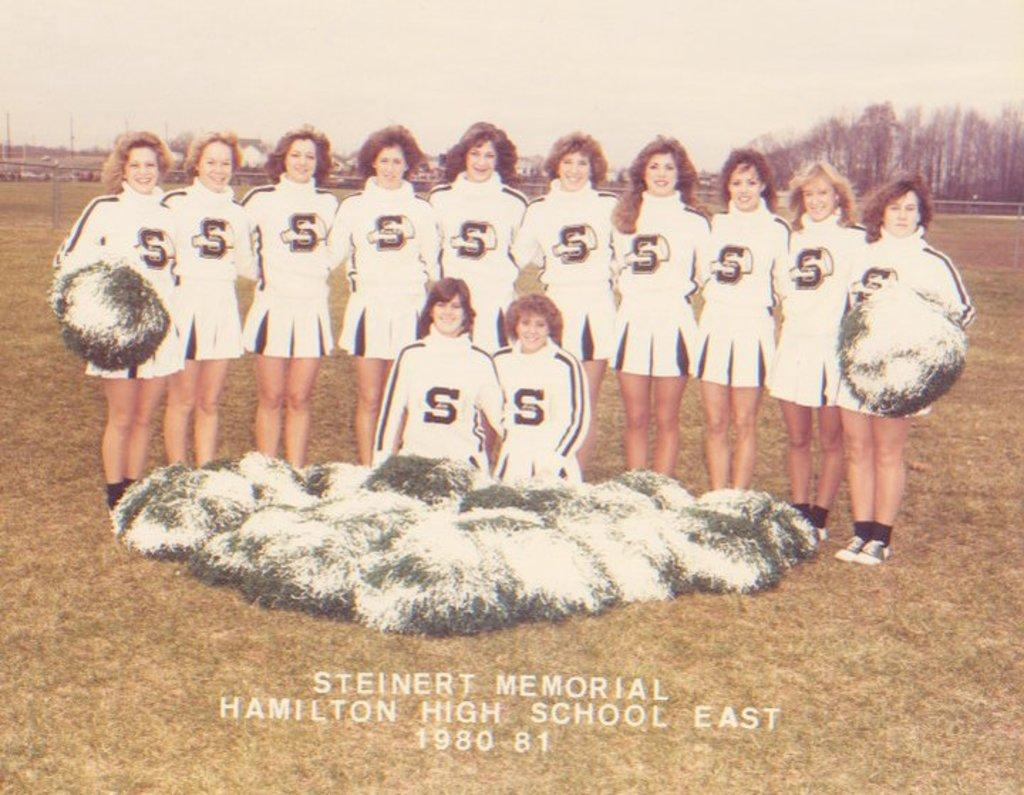<image>
Create a compact narrative representing the image presented. A group of cheerleaders from Steinert Memorial Hamilton High School East. 